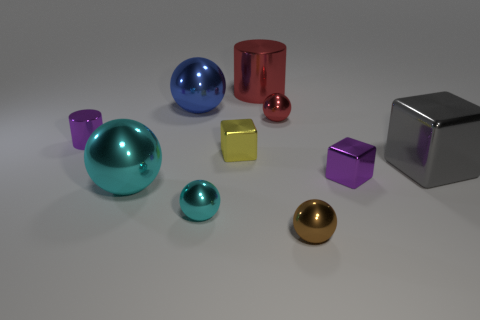Subtract all brown spheres. How many spheres are left? 4 Subtract all red spheres. How many spheres are left? 4 Subtract all yellow balls. Subtract all brown cylinders. How many balls are left? 5 Subtract all blocks. How many objects are left? 7 Add 5 matte balls. How many matte balls exist? 5 Subtract 1 purple cylinders. How many objects are left? 9 Subtract all purple things. Subtract all tiny brown things. How many objects are left? 7 Add 8 small cyan metal things. How many small cyan metal things are left? 9 